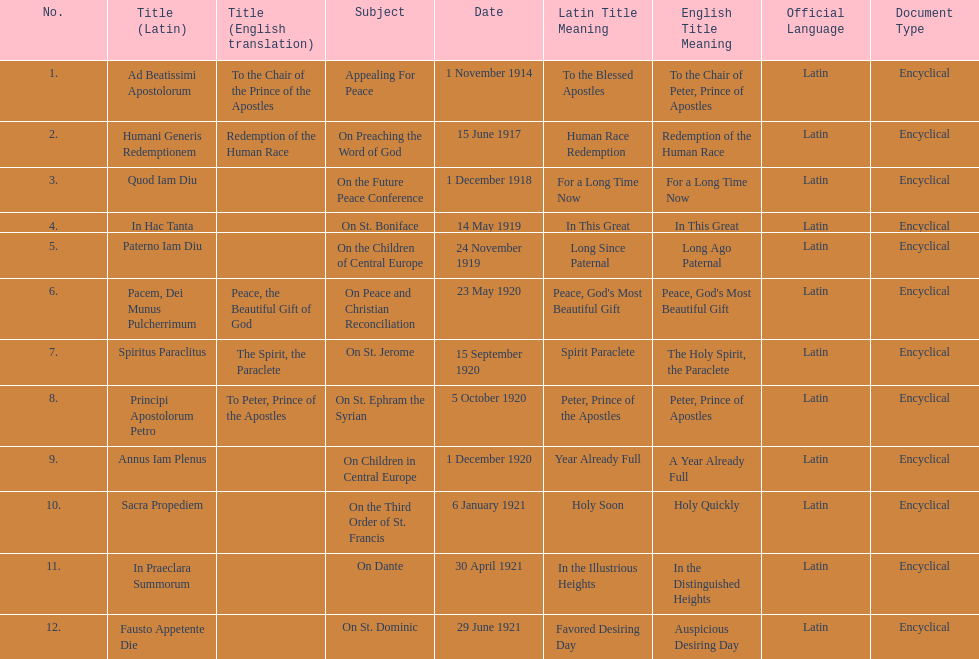What is the subject listed after appealing for peace? On Preaching the Word of God. 